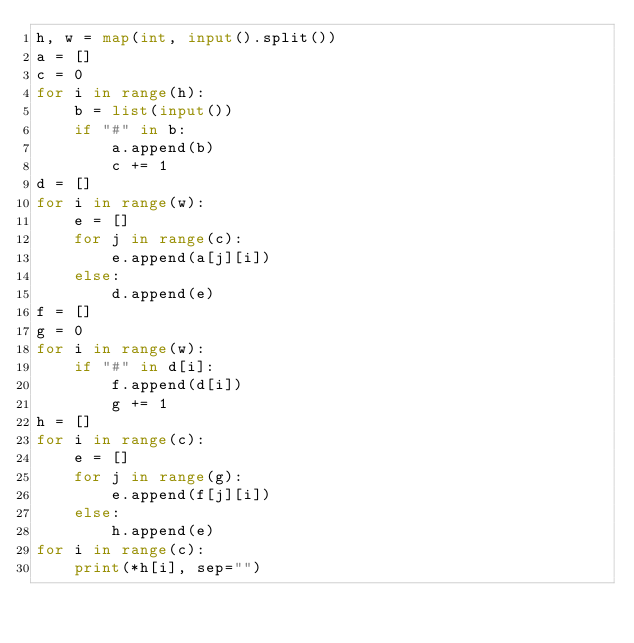<code> <loc_0><loc_0><loc_500><loc_500><_Python_>h, w = map(int, input().split())
a = []
c = 0
for i in range(h):
    b = list(input())
    if "#" in b:
        a.append(b)
        c += 1
d = []
for i in range(w):
    e = []
    for j in range(c):
        e.append(a[j][i])
    else:
        d.append(e)
f = []
g = 0
for i in range(w):
    if "#" in d[i]:
        f.append(d[i])
        g += 1
h = []
for i in range(c):
    e = []
    for j in range(g):
        e.append(f[j][i])
    else:
        h.append(e)
for i in range(c):
    print(*h[i], sep="")</code> 